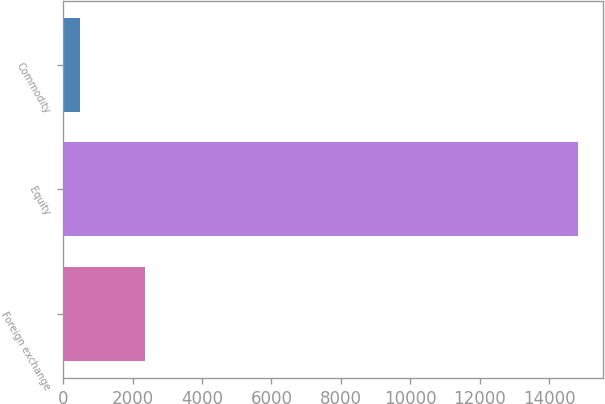Convert chart. <chart><loc_0><loc_0><loc_500><loc_500><bar_chart><fcel>Foreign exchange<fcel>Equity<fcel>Commodity<nl><fcel>2365<fcel>14831<fcel>488<nl></chart> 